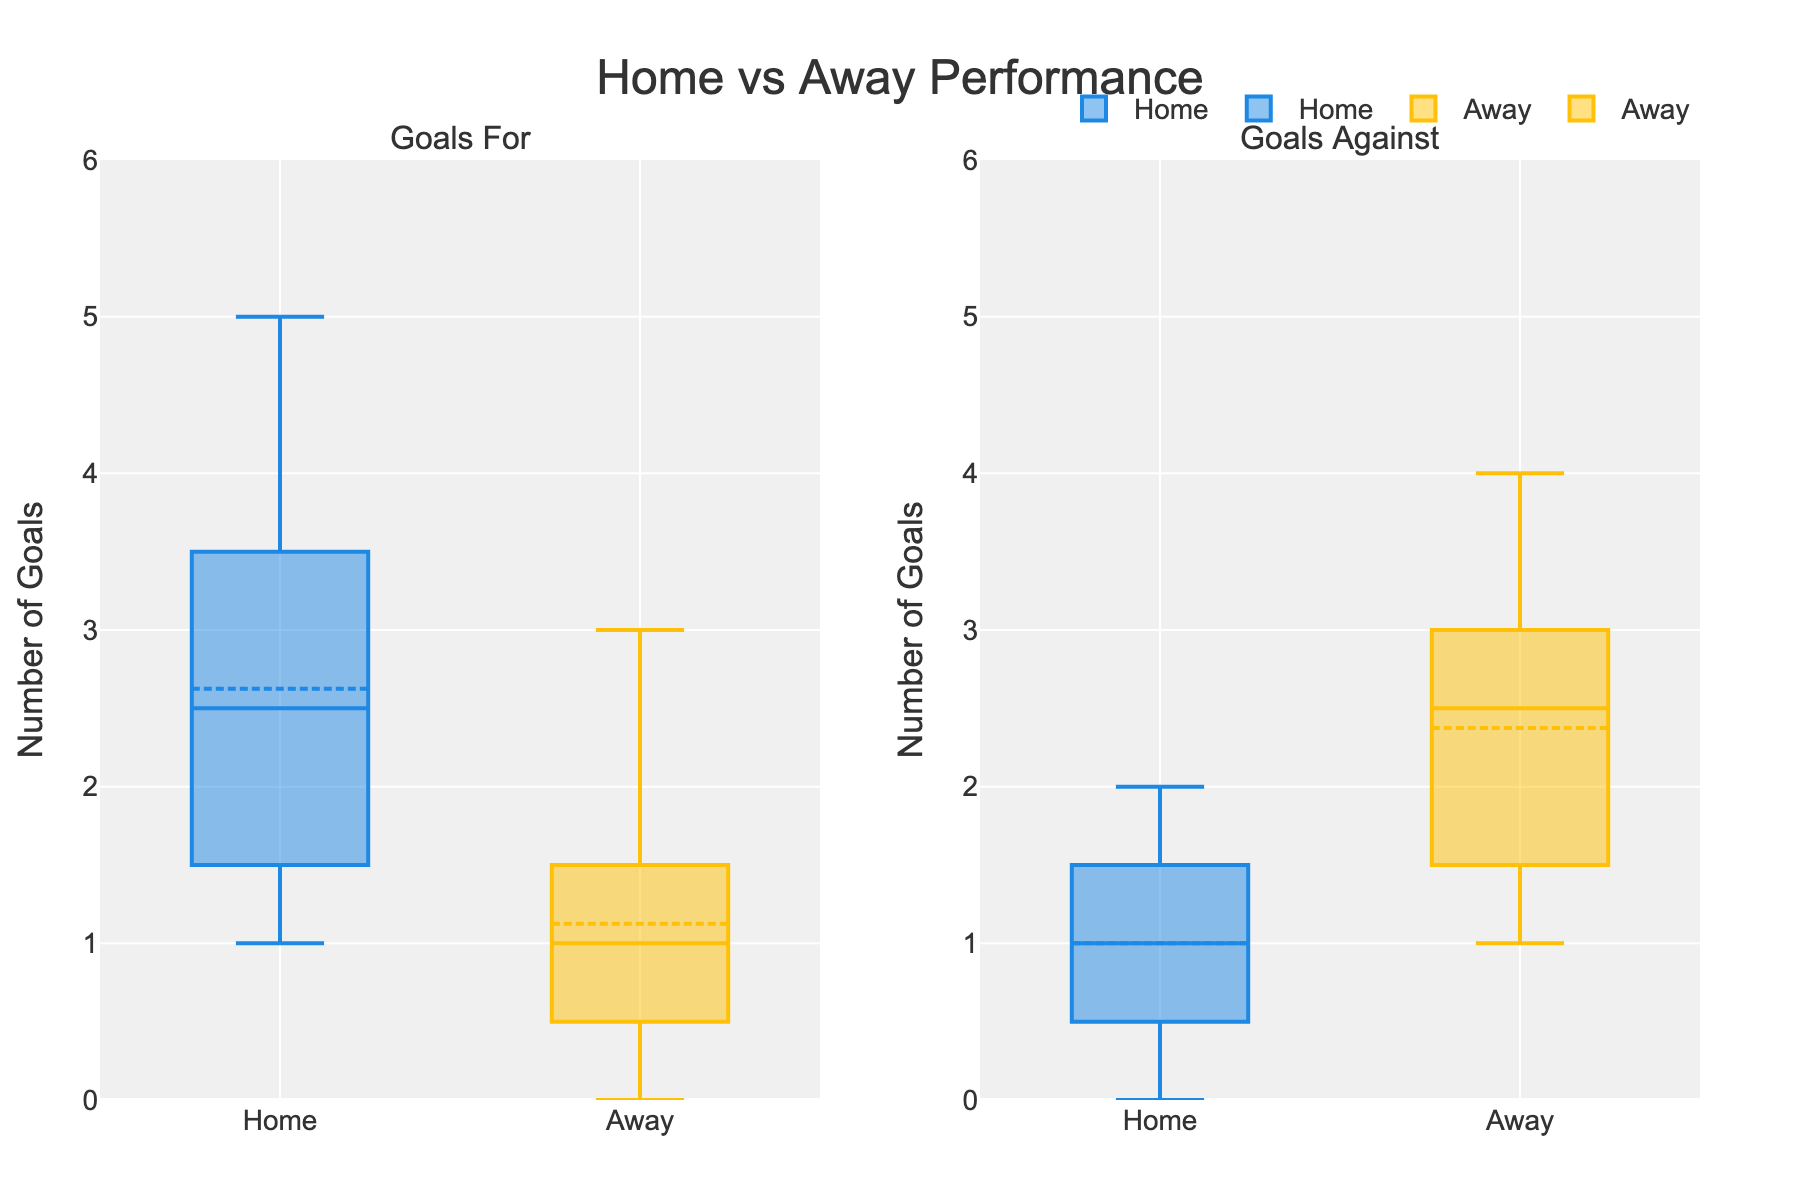What is the title of the figure? The title is prominently displayed at the top of the plot. It usually helps to understand what the plot is about.
Answer: Home vs Away Performance What is the range of the y-axis? The y-axis is typically marked on the left side of the plot. It shows the range of values for the number of goals.
Answer: 0 to 6 Which color represents home games? Colors on the plots are usually defined in the legend or can be observed visually.
Answer: Blue Which side of the figure shows information about 'Goals For'? The figure is divided into two parts by column titles indicated at the top of each column.
Answer: Left What is the median number of goals for home games? The median is represented by the line inside the box of the box plot for the home games on the plot.
Answer: 2 Which group has a higher median number of goals scored against them? Compare the median lines inside the boxes represented for 'Goals Against' in both home and away categories.
Answer: Away What is the median number of goals conceded in away games? Check the line inside the box plot that represents 'Goals Against' for away games.
Answer: 2.5 How do the interquartile ranges (IQRs) compare between home and away goals scored? The IQR is the range between the first quartile (Q1) and the third quartile (Q3). Compare the height of the boxes for home and away under 'Goals For'.
Answer: Home: 1.75, Away: 1.5 Which group has a higher variability in goals scored? Variability can be observed by checking the length of the whiskers and the spread of the box. Compare the home and away box plots under 'Goals For'.
Answer: Home How many data points are represented for away games? Each data point typically corresponds to a match. Count the number of matches listed under away games.
Answer: 8 